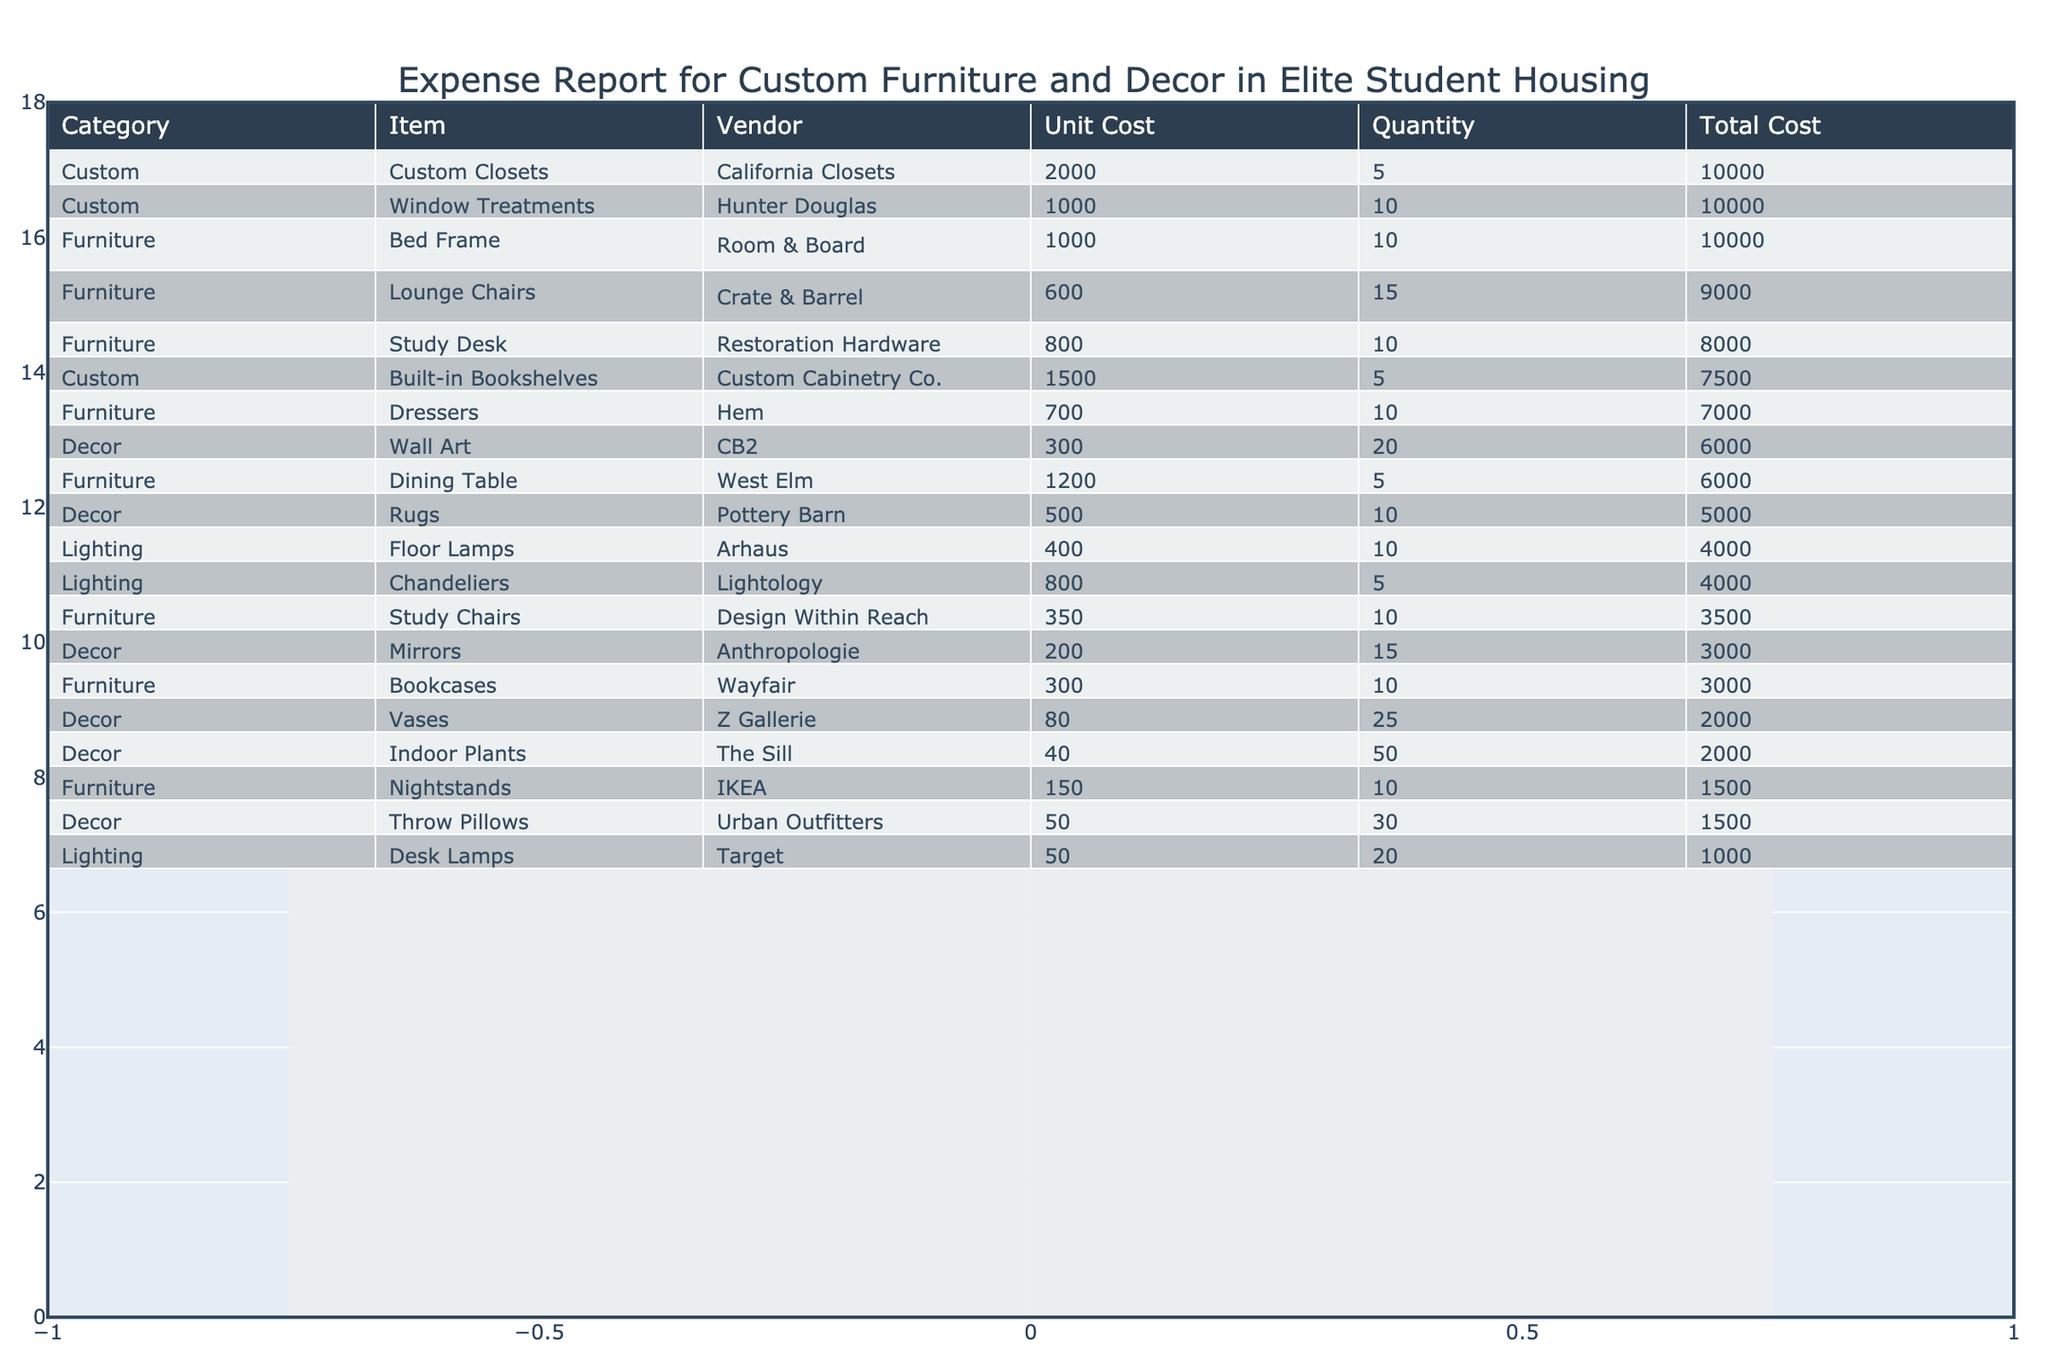What is the total cost for furniture items? To find the total cost for furniture items, we sum the 'Total Cost' for all rows where the 'Category' is 'Furniture'. The relevant totals are: 8000 (Study Desk) + 10000 (Bed Frame) + 6000 (Dining Table) + 9000 (Lounge Chairs) + 3500 (Study Chairs) + 1500 (Nightstands) + 3000 (Bookcases) + 7000 (Dressers) = 52500.
Answer: 52500 Which vendor provided the most expensive item? The most expensive item in the table is 'Custom Closets' with a total cost of 10000 from 'California Closets'. We can identify this by examining the 'Total Cost' column and comparing all values.
Answer: California Closets How many items are listed under the decor category? The decor category includes the following items: Wall Art, Rugs, Mirrors, Throw Pillows, Vases, Indoor Plants. That makes a total of 6 items in the ‘Decor’ category.
Answer: 6 Is the total cost of custom items greater than the total cost of the decor items? First, we calculate the total cost of custom items: 7500 (Built-in Bookshelves) + 10000 (Custom Closets) + 10000 (Window Treatments) = 27500. Next, we do the same for decor items: 6000 (Wall Art) + 5000 (Rugs) + 3000 (Mirrors) + 1500 (Throw Pillows) + 2000 (Vases) + 2000 (Indoor Plants) = 20000. Since 27500 > 20000, custom items cost more.
Answer: Yes What is the average unit cost of furniture items? To find the average unit cost, we first sum all unit costs of furniture items: 800 (Study Desk) + 1000 (Bed Frame) + 1200 (Dining Table) + 600 (Lounge Chairs) + 350 (Study Chairs) + 150 (Nightstands) + 300 (Bookcases) + 700 (Dressers) = 5100. There are 8 furniture items, so we divide 5100 by 8 to get the average, which is 637.5.
Answer: 637.5 How many more items in the table are provided by West Elm compared to IKEA? West Elm has 1 item (Dining Table), while IKEA also has 1 item (Nightstands). The difference between the two counts is 1 - 1 = 0.
Answer: 0 